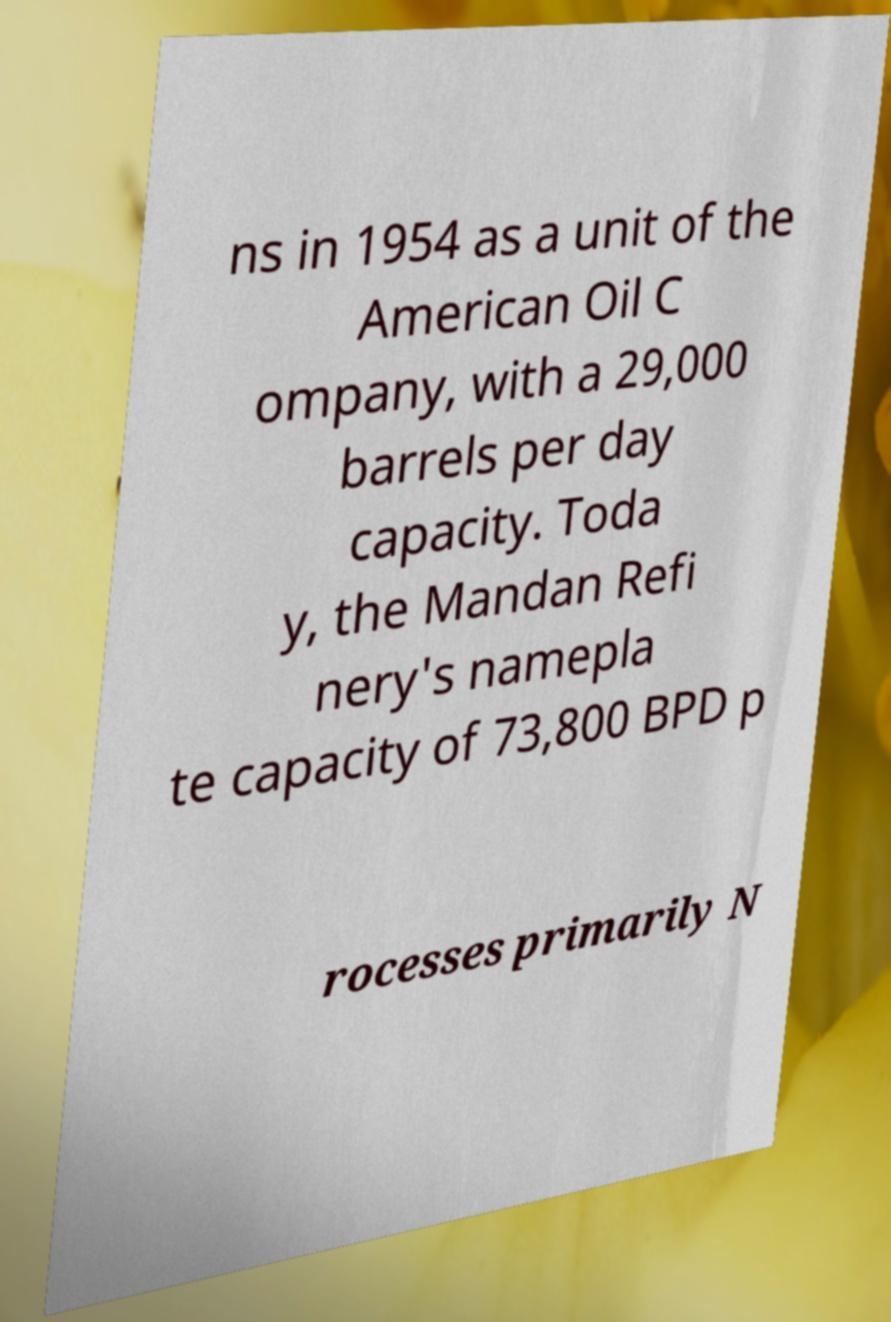What messages or text are displayed in this image? I need them in a readable, typed format. ns in 1954 as a unit of the American Oil C ompany, with a 29,000 barrels per day capacity. Toda y, the Mandan Refi nery's namepla te capacity of 73,800 BPD p rocesses primarily N 